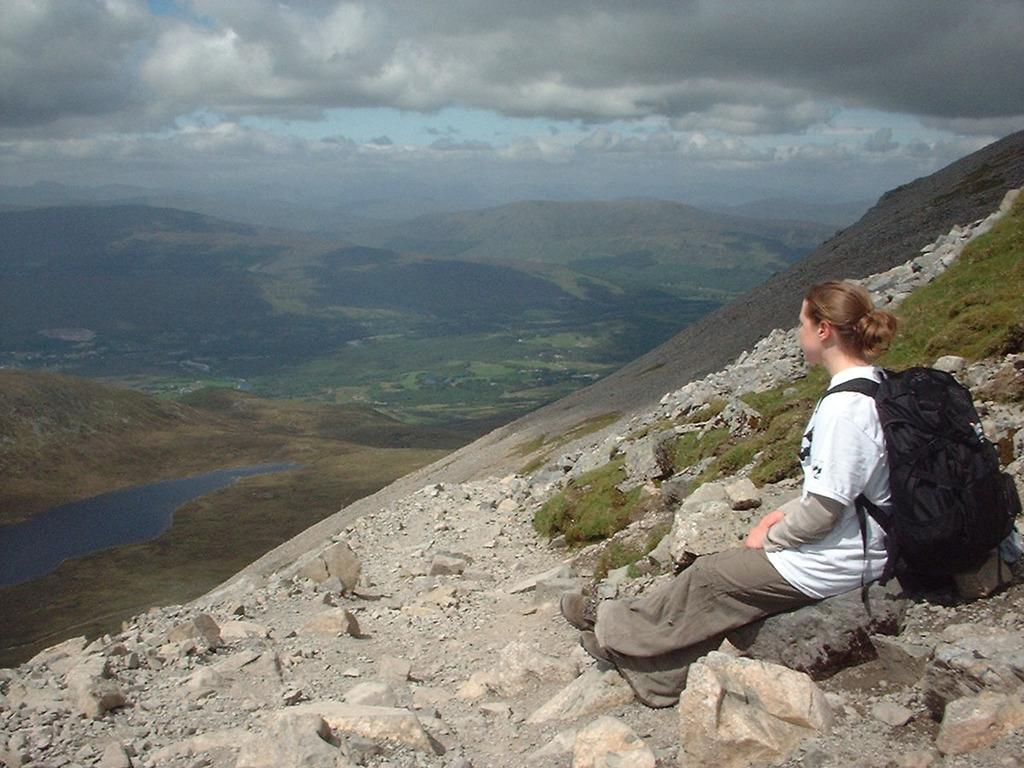Where is the woman located in the image? The woman is on the right side of the image. What is the woman sitting on? The woman is seated on a rock. What is the woman wearing? The woman is wearing a bag. What can be seen in the background of the image? There is water, trees, hills, and clouds visible in the background of the image. How many times does the woman laugh in the image? The image does not show the woman laughing, so it cannot be determined how many times she laughs. 